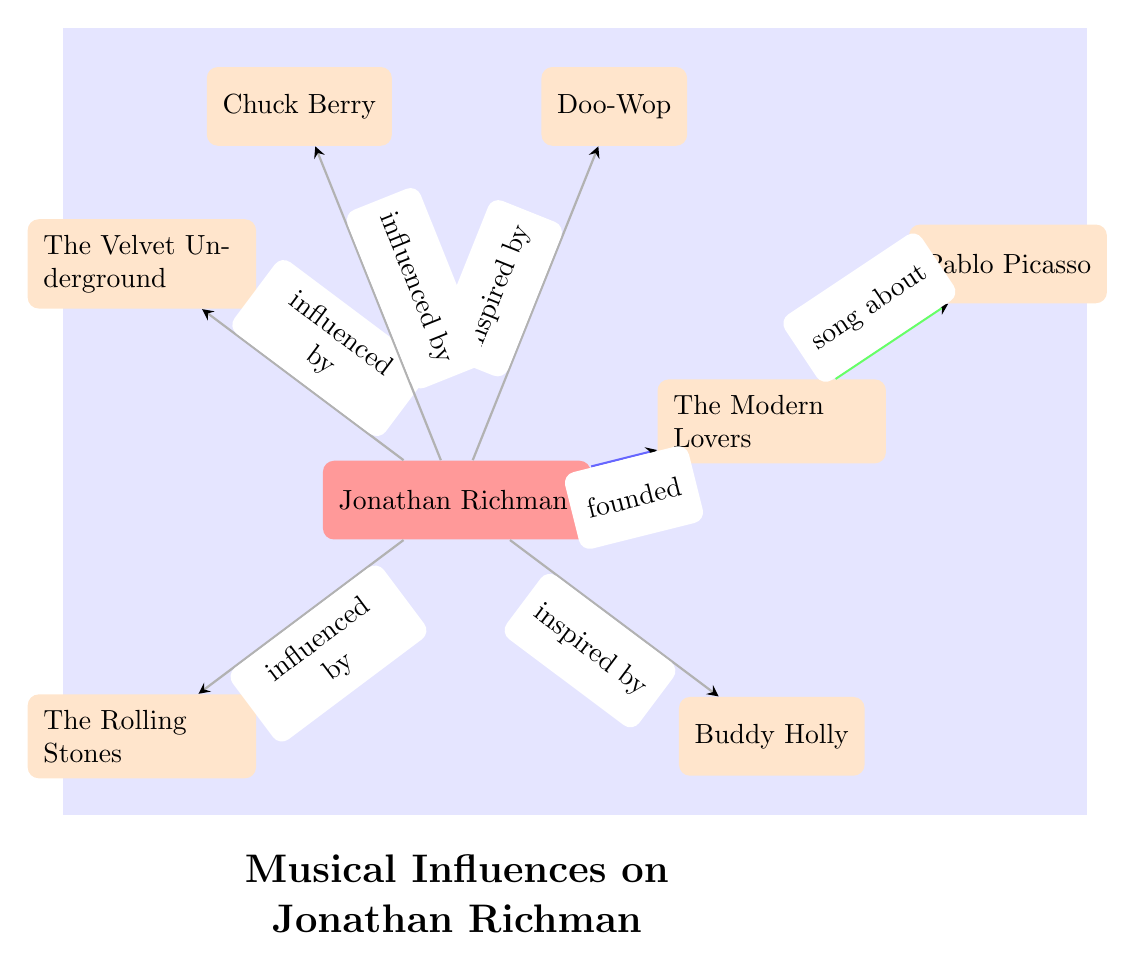What is the primary genre represented by Jonathan Richman? The node connected directly to Jonathan Richman indicates that he is represented by the main color, which signifies the primary genre of his influence in the diagram.
Answer: Jonathan Richman How many artists are directly shown as influences on Jonathan Richman? By counting the nodes that have direct edges (influences) pointing towards Jonathan Richman, we find there are five distinct influences.
Answer: 5 Which artist is shown as being influenced by Chuck Berry? The arrows indicate the directional relationships. Since there is no arrow leading to any node from Chuck Berry, we conclude that no artist is shown to be influenced by him in this diagram.
Answer: None What genre does The Modern Lovers represent in relation to Jonathan Richman? The node for The Modern Lovers has a direct arrow labeled "founded," indicating that this band was created by Jonathan Richman as a result of his influences.
Answer: Founded How does Jonathan Richman relate to The Velvet Underground? The diagram shows a directed edge labeled "influenced by," indicating Jonathan Richman was influenced by The Velvet Underground. This easy connection describes the nature of their relationship clearly.
Answer: Influenced by What is the connection between The Modern Lovers and Pablo Picasso? There is an edge labeled "song about" leading from The Modern Lovers to Pablo Picasso, meaning that a specific song by The Modern Lovers is dedicated to or inspired by Picasso.
Answer: Song about 